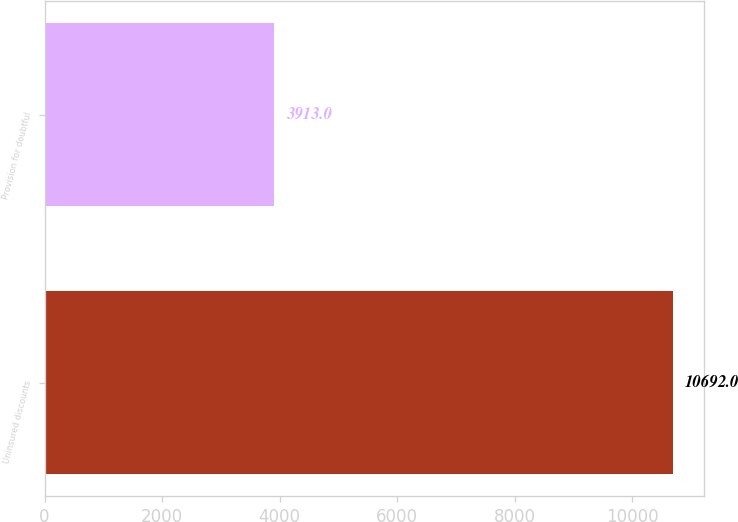Convert chart. <chart><loc_0><loc_0><loc_500><loc_500><bar_chart><fcel>Uninsured discounts<fcel>Provision for doubtful<nl><fcel>10692<fcel>3913<nl></chart> 